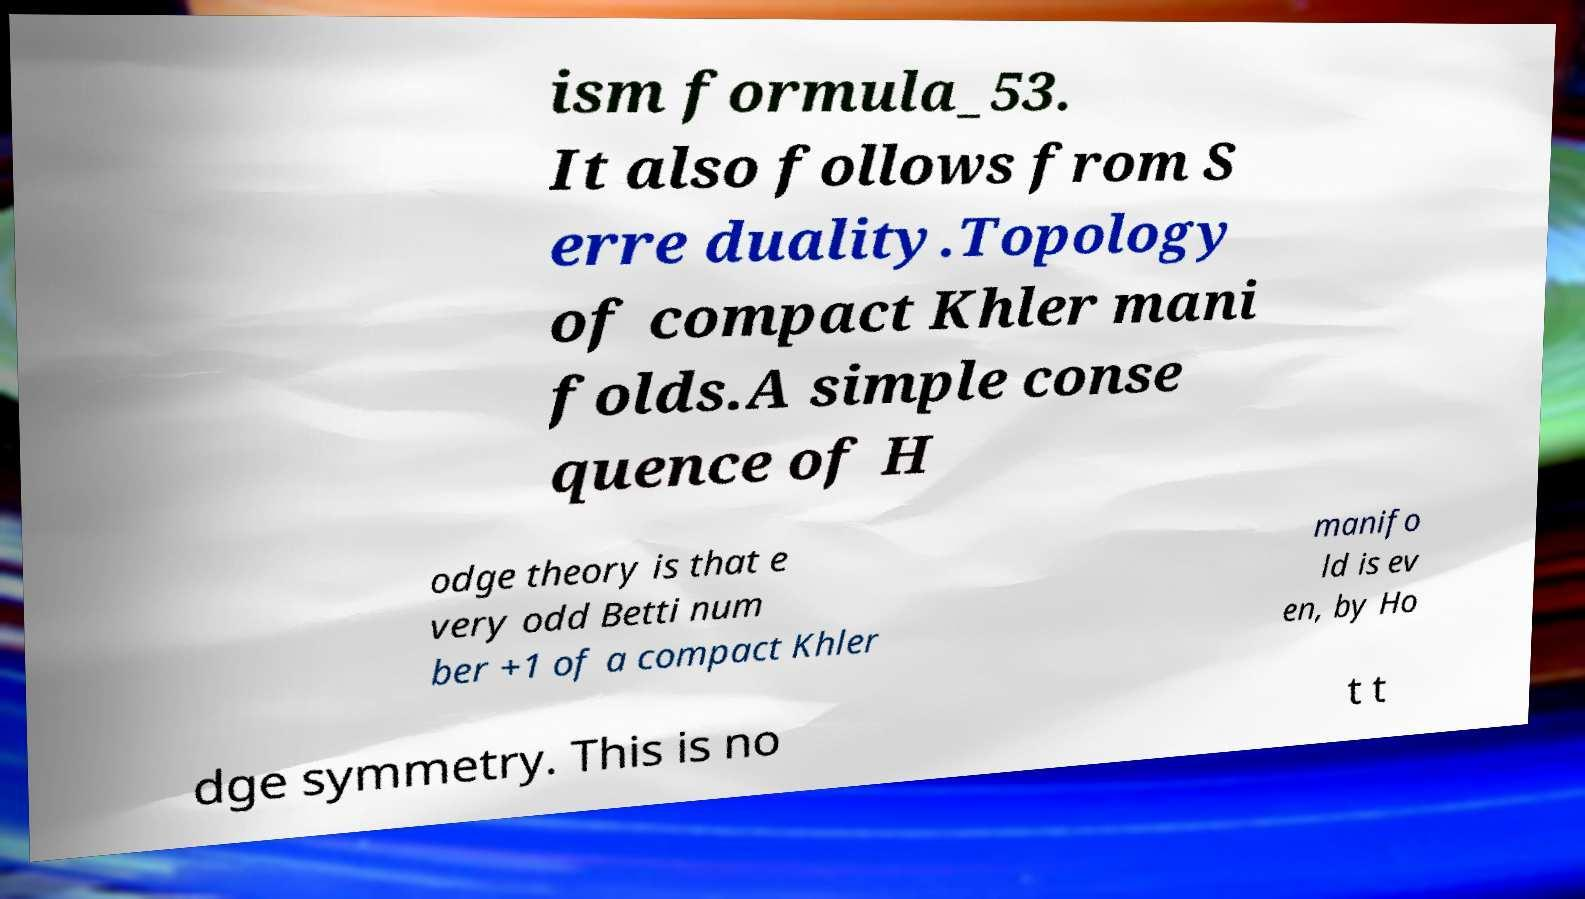For documentation purposes, I need the text within this image transcribed. Could you provide that? ism formula_53. It also follows from S erre duality.Topology of compact Khler mani folds.A simple conse quence of H odge theory is that e very odd Betti num ber +1 of a compact Khler manifo ld is ev en, by Ho dge symmetry. This is no t t 